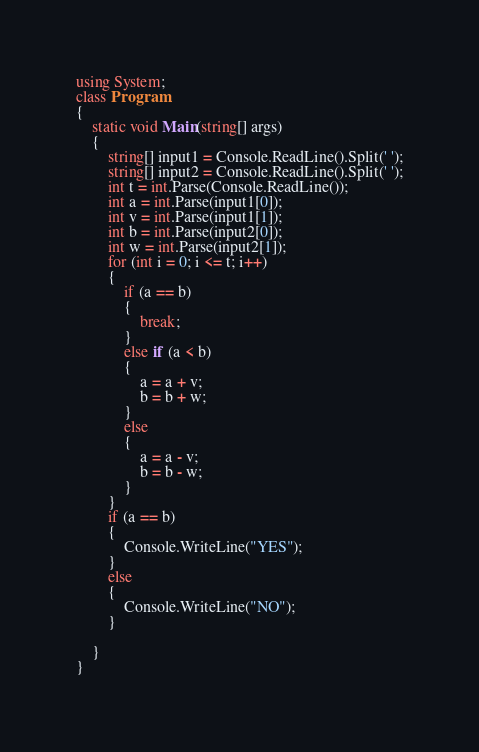Convert code to text. <code><loc_0><loc_0><loc_500><loc_500><_C#_>using System;
class Program
{
	static void Main(string[] args)
	{
		string[] input1 = Console.ReadLine().Split(' ');
		string[] input2 = Console.ReadLine().Split(' ');
		int t = int.Parse(Console.ReadLine());
		int a = int.Parse(input1[0]);
		int v = int.Parse(input1[1]);
		int b = int.Parse(input2[0]);
		int w = int.Parse(input2[1]);
		for (int i = 0; i <= t; i++)
		{
			if (a == b)
            {
                break;
            }
			else if (a < b)
			{
				a = a + v;
				b = b + w;
			}
			else
			{
				a = a - v;
				b = b - w;
			}
		}
		if (a == b)
		{
			Console.WriteLine("YES");
		}
		else
		{
			Console.WriteLine("NO");
		}

	}
}</code> 